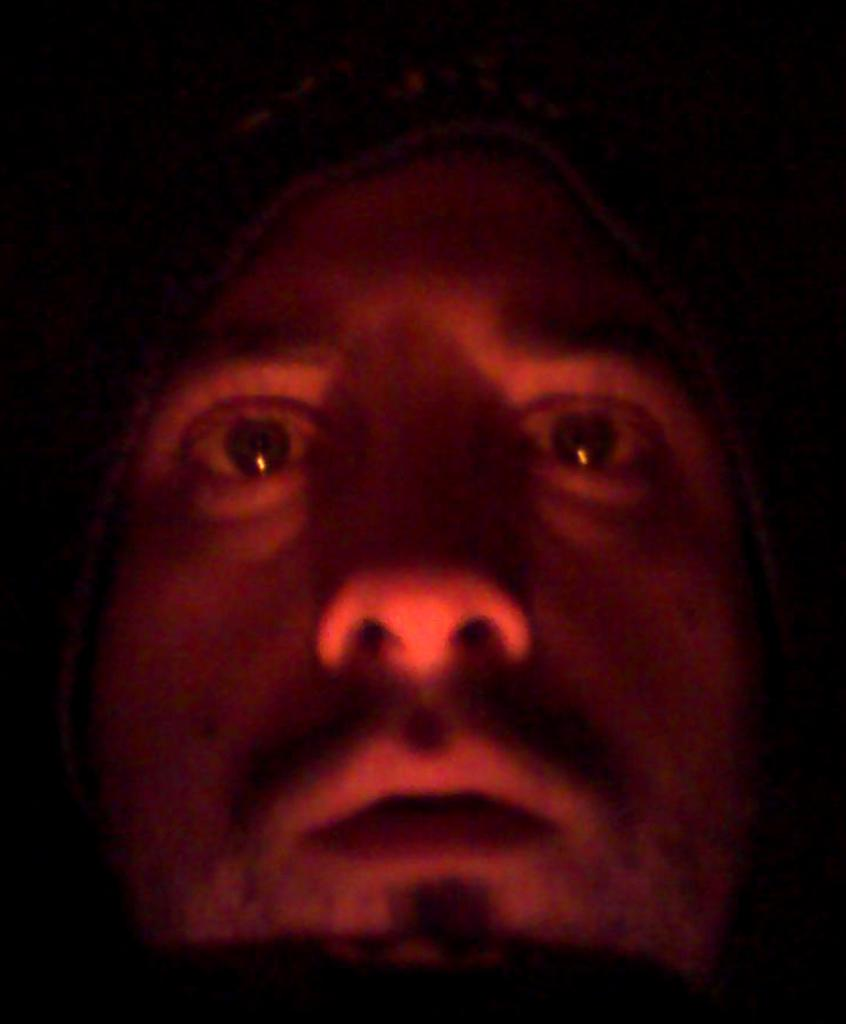What is the main subject of the image? The main subject of the image is a man's face. What is the man wearing on his head? The man is wearing a cap. What is the lighting condition in the image? The man is in the dark. Is there any visible light source in the image? Yes, there is a red light on the man. What type of sack is the man carrying in the image? There is no sack present in the image; the man's face is the main subject. Is the man holding a pot in the image? No, the man is not holding a pot in the image; he is wearing a cap and has a red light on his face. 